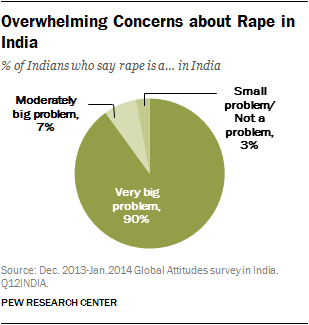What does this data suggest about public opinion on rape in India? The data suggest that the vast majority of Indians, 90%, consider rape to be a 'Very big problem' in the country. This highlights significant public concern over this issue, with only a small percentage of the population considering it less severe. 